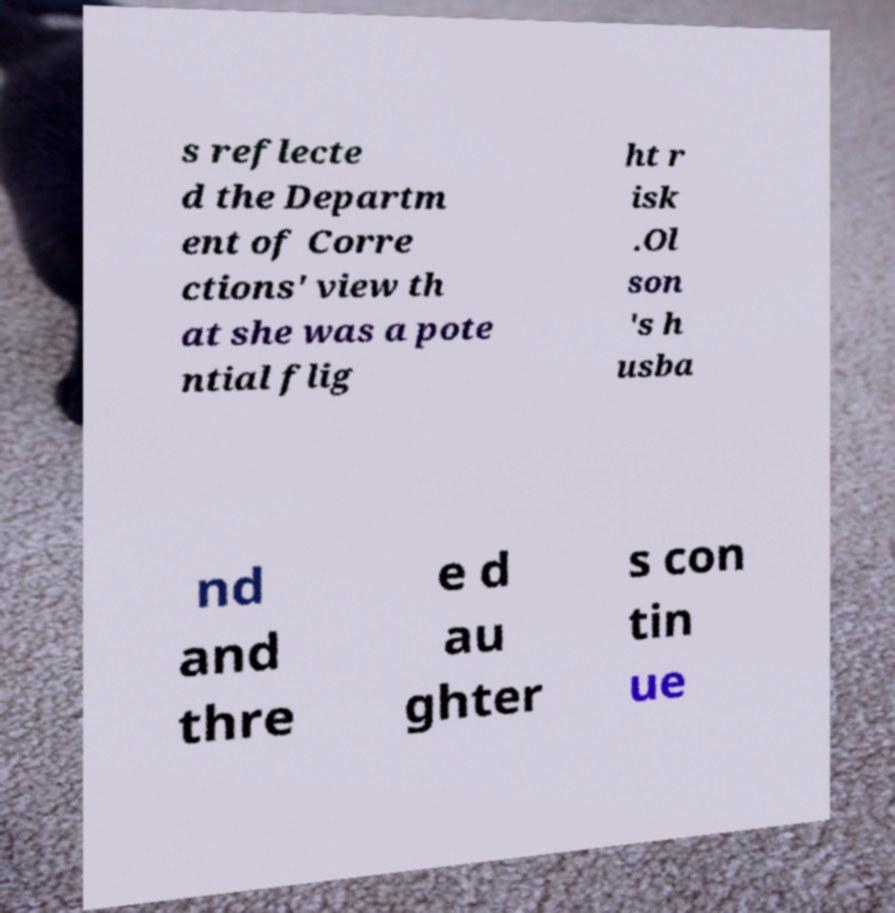Please identify and transcribe the text found in this image. s reflecte d the Departm ent of Corre ctions' view th at she was a pote ntial flig ht r isk .Ol son 's h usba nd and thre e d au ghter s con tin ue 